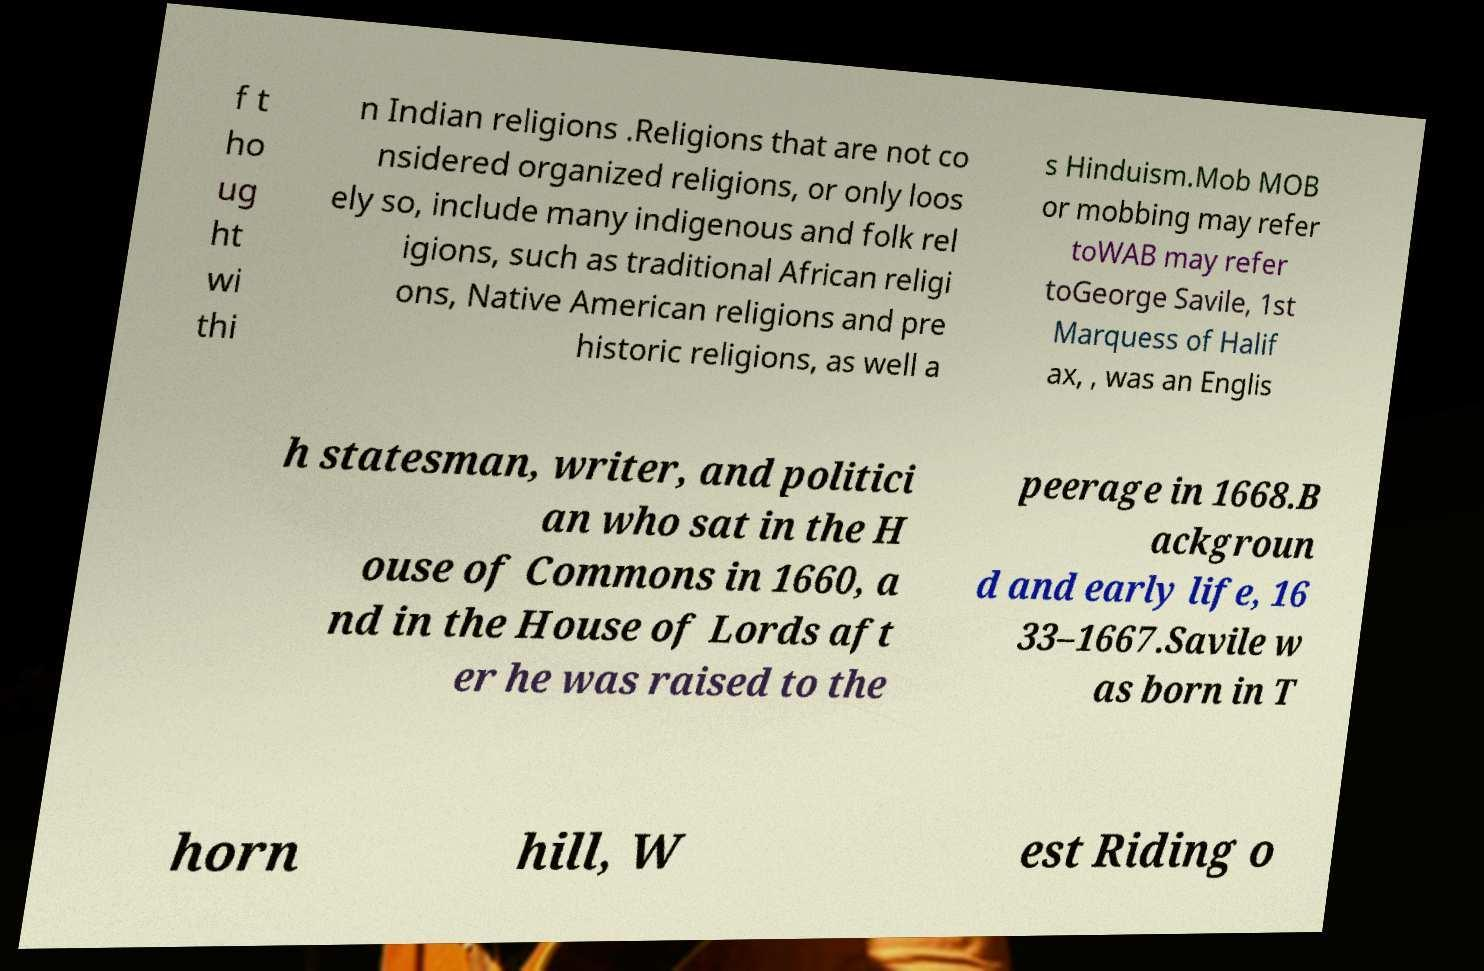What messages or text are displayed in this image? I need them in a readable, typed format. f t ho ug ht wi thi n Indian religions .Religions that are not co nsidered organized religions, or only loos ely so, include many indigenous and folk rel igions, such as traditional African religi ons, Native American religions and pre historic religions, as well a s Hinduism.Mob MOB or mobbing may refer toWAB may refer toGeorge Savile, 1st Marquess of Halif ax, , was an Englis h statesman, writer, and politici an who sat in the H ouse of Commons in 1660, a nd in the House of Lords aft er he was raised to the peerage in 1668.B ackgroun d and early life, 16 33–1667.Savile w as born in T horn hill, W est Riding o 